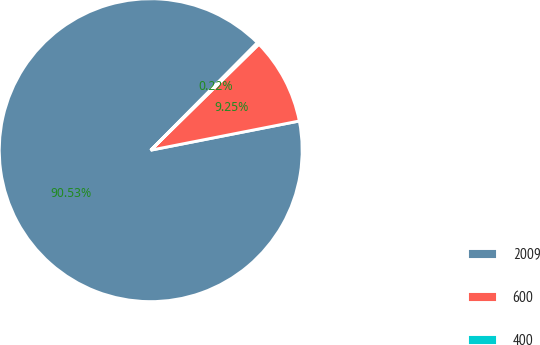Convert chart. <chart><loc_0><loc_0><loc_500><loc_500><pie_chart><fcel>2009<fcel>600<fcel>400<nl><fcel>90.53%<fcel>9.25%<fcel>0.22%<nl></chart> 